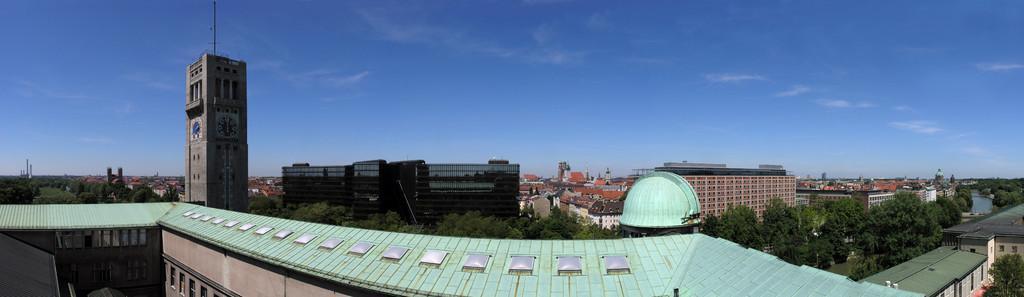In one or two sentences, can you explain what this image depicts? It is the panorama image in which we can see the entire city. In the image there are so many buildings. At the top there is the sky. On the left side there is a building to which there is a clock. At the bottom there are some trees. 